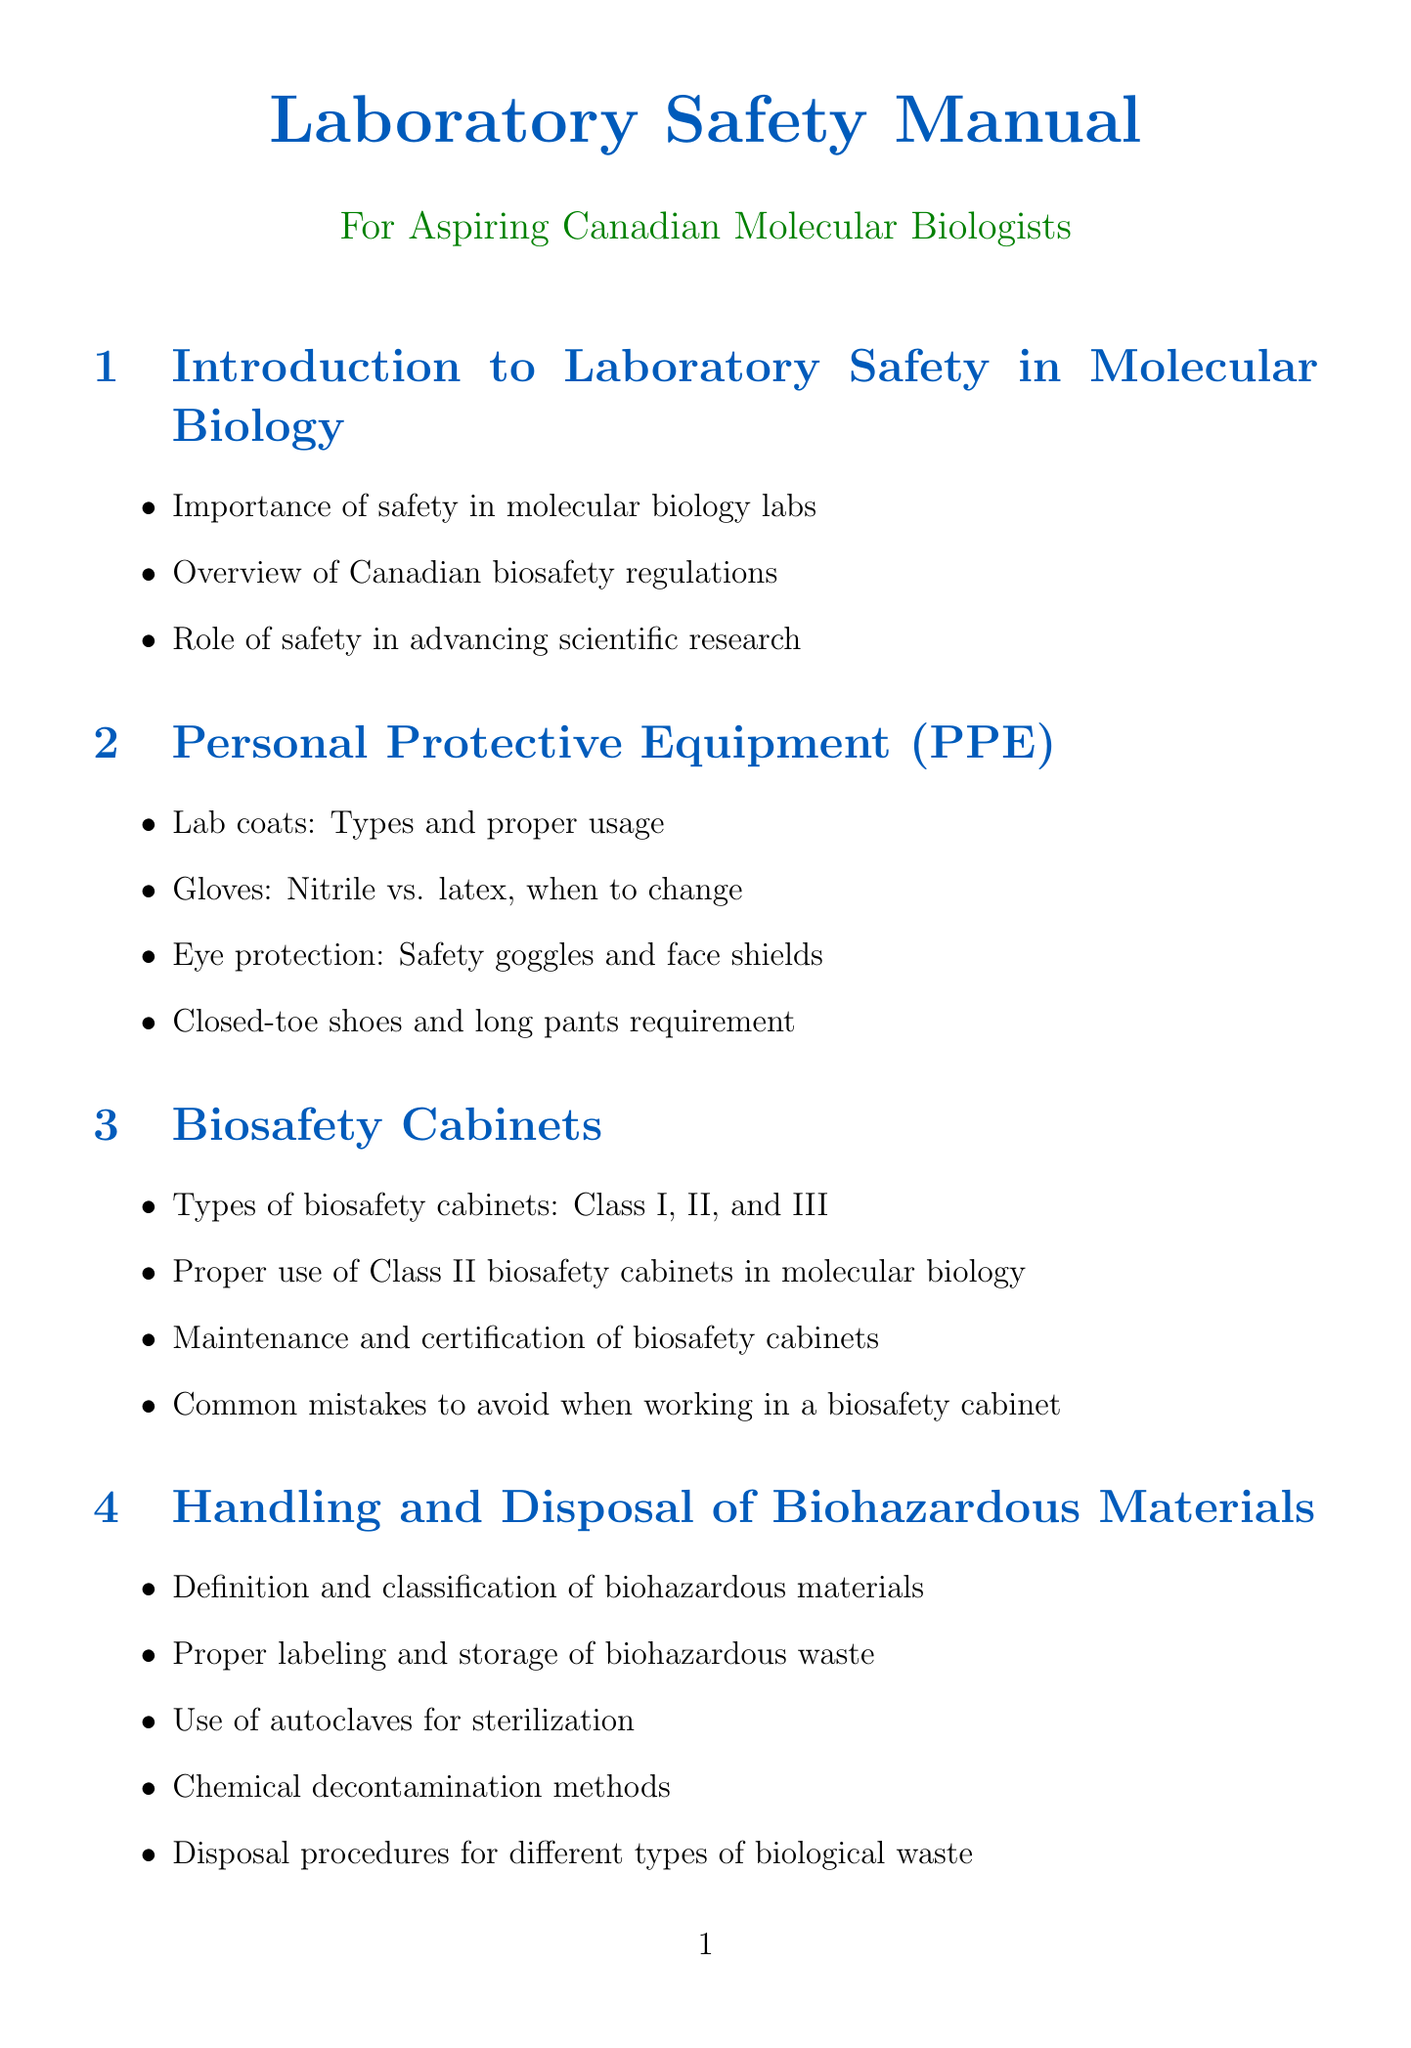What is the importance of safety in molecular biology labs? The document states that the importance of safety in molecular biology labs encompasses not only regulatory compliance but also the protection of researchers and the integrity of experiments.
Answer: Importance of safety in molecular biology labs What are the types of biosafety cabinets mentioned? The document lists three types of biosafety cabinets: Class I, Class II, and Class III.
Answer: Class I, Class II, Class III What is the required footwear in the laboratory? The document specifies that closed-toe shoes are required in the laboratory.
Answer: Closed-toe shoes What kind of waste needs proper labeling and storage? The document emphasizes that biohazardous waste requires proper labeling and storage to ensure safety.
Answer: Biohazardous waste What is the training requirement for Canadian molecular biology labs? The document mentions that required safety training for Canadian molecular biology labs is included in the section on Training and Certification.
Answer: Required safety training Why are aseptic techniques important in molecular biology? The document states that aseptic techniques are crucial to preventing contamination in molecular biology experiments.
Answer: Preventing contamination Which method is mentioned for sterilizing biological waste? The document mentions the use of autoclaves for sterilization of biological waste.
Answer: Autoclaves What is emphasized for the use of chemical reagents in a lab? The document highlights the proper storage and handling of common molecular biology reagents for safety.
Answer: Proper storage and handling What are the emergency procedures addressed in the manual? The document addresses emergency procedures such as the use of eyewash stations and safety showers.
Answer: Eyewash stations and safety showers 